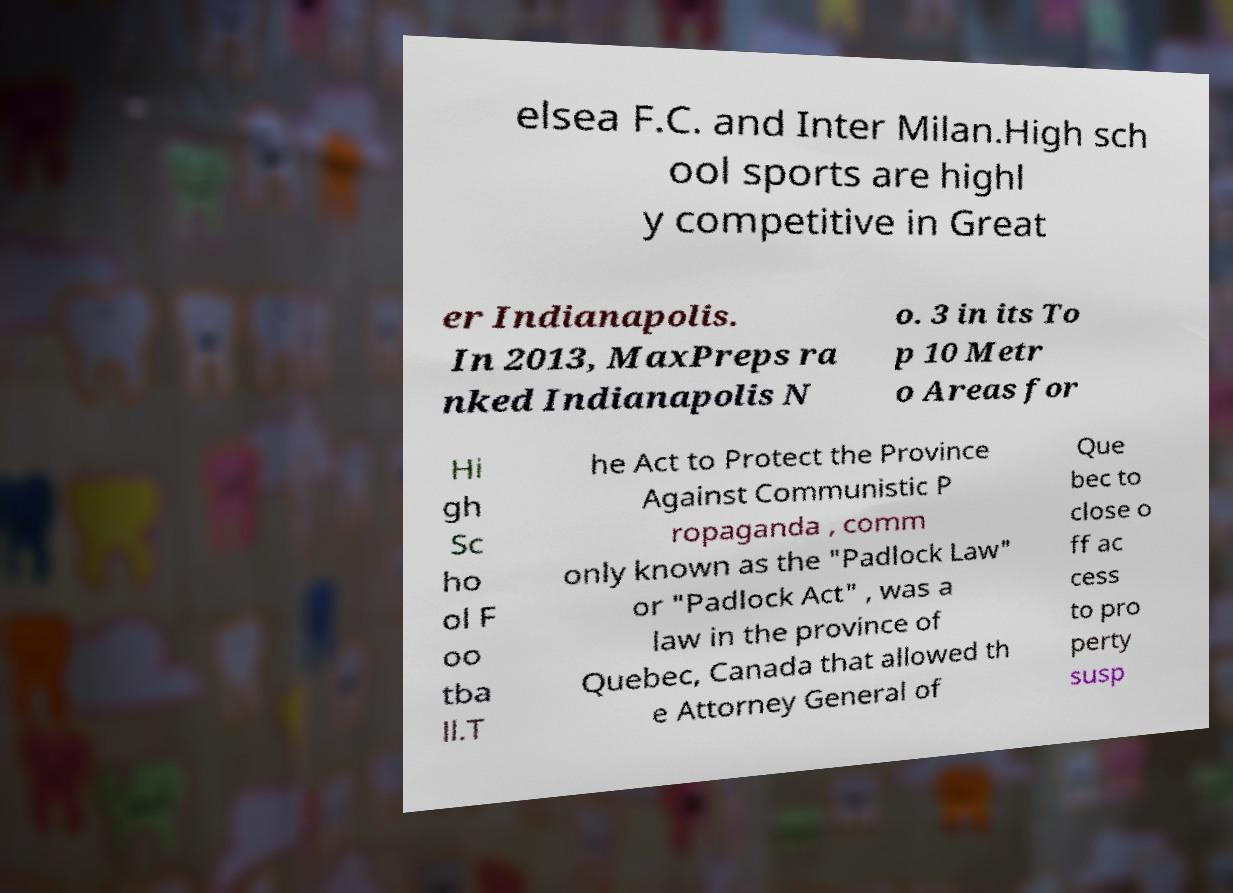Can you accurately transcribe the text from the provided image for me? elsea F.C. and Inter Milan.High sch ool sports are highl y competitive in Great er Indianapolis. In 2013, MaxPreps ra nked Indianapolis N o. 3 in its To p 10 Metr o Areas for Hi gh Sc ho ol F oo tba ll.T he Act to Protect the Province Against Communistic P ropaganda , comm only known as the "Padlock Law" or "Padlock Act" , was a law in the province of Quebec, Canada that allowed th e Attorney General of Que bec to close o ff ac cess to pro perty susp 